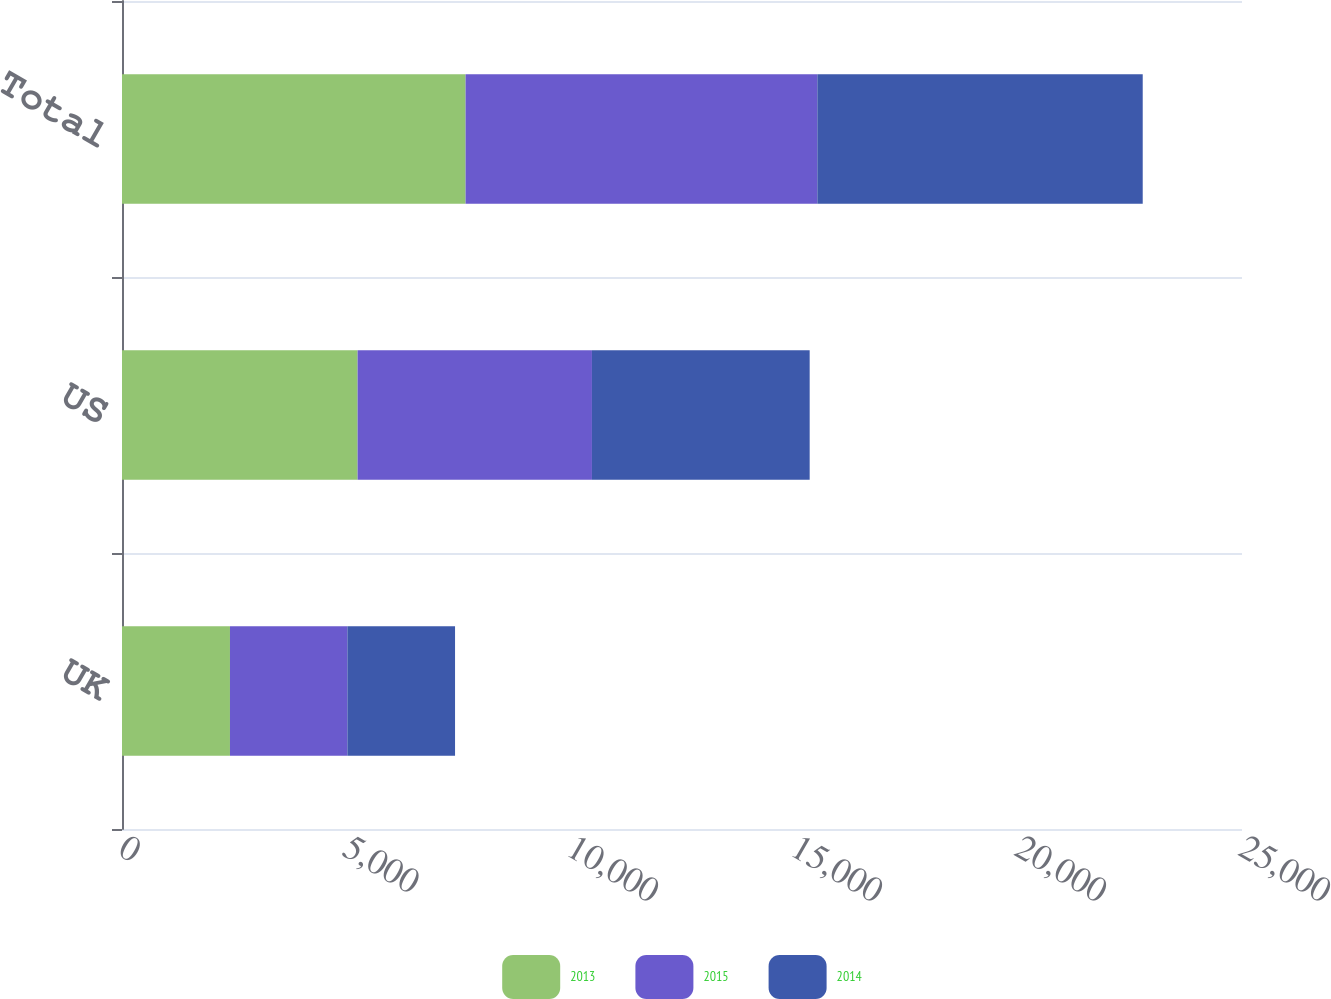<chart> <loc_0><loc_0><loc_500><loc_500><stacked_bar_chart><ecel><fcel>UK<fcel>US<fcel>Total<nl><fcel>2013<fcel>2410<fcel>5259<fcel>7669<nl><fcel>2015<fcel>2621<fcel>5231<fcel>7852<nl><fcel>2014<fcel>2403<fcel>4860<fcel>7263<nl></chart> 